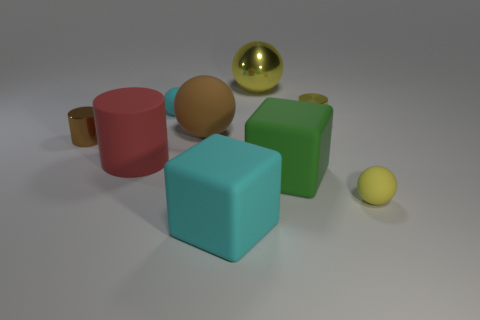Does the cyan rubber block have the same size as the brown metallic object?
Offer a very short reply. No. How many tiny objects are blue cylinders or yellow metallic things?
Provide a succinct answer. 1. What is the shape of the brown metal thing?
Your response must be concise. Cylinder. Are there any tiny brown cylinders that have the same material as the big yellow thing?
Keep it short and to the point. Yes. Are there more large cylinders than red cubes?
Provide a succinct answer. Yes. Is the material of the red thing the same as the large yellow thing?
Keep it short and to the point. No. What number of rubber objects are large cylinders or green cylinders?
Provide a short and direct response. 1. What is the color of the other matte sphere that is the same size as the yellow rubber ball?
Provide a short and direct response. Cyan. What number of other small things have the same shape as the green thing?
Provide a short and direct response. 0. How many cylinders are tiny shiny things or green objects?
Give a very brief answer. 2. 